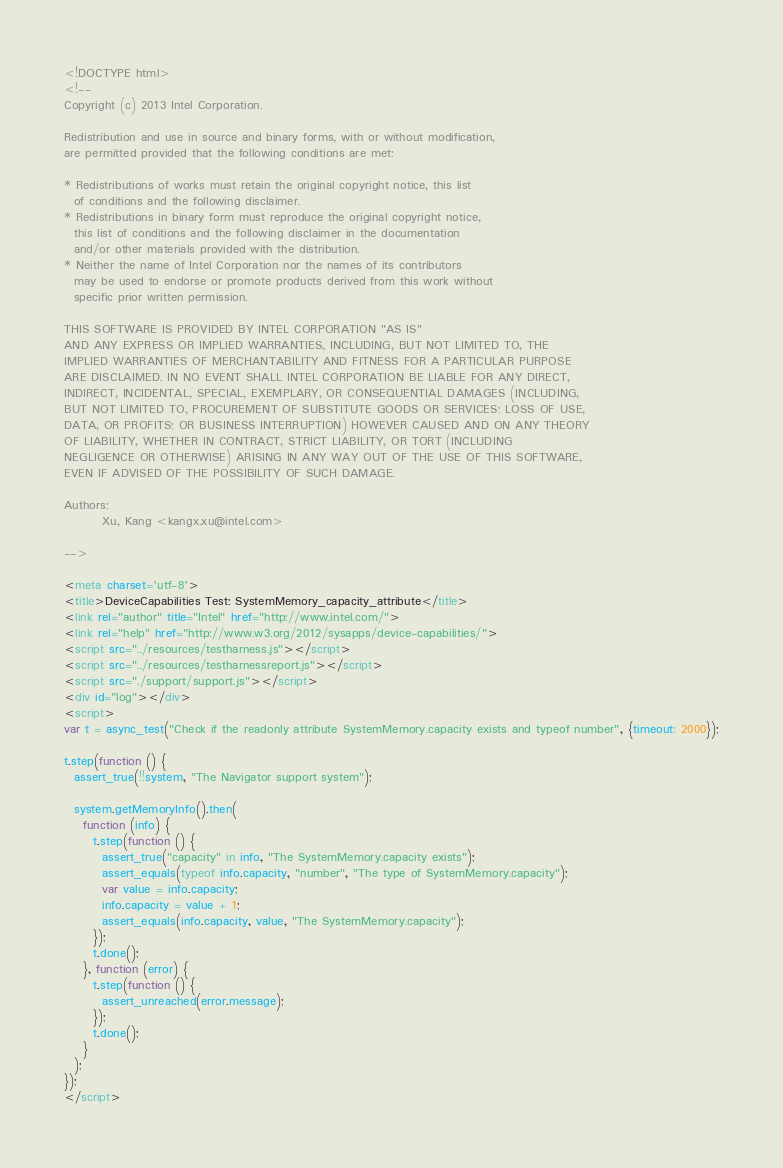Convert code to text. <code><loc_0><loc_0><loc_500><loc_500><_HTML_><!DOCTYPE html>
<!--
Copyright (c) 2013 Intel Corporation.

Redistribution and use in source and binary forms, with or without modification,
are permitted provided that the following conditions are met:

* Redistributions of works must retain the original copyright notice, this list
  of conditions and the following disclaimer.
* Redistributions in binary form must reproduce the original copyright notice,
  this list of conditions and the following disclaimer in the documentation
  and/or other materials provided with the distribution.
* Neither the name of Intel Corporation nor the names of its contributors
  may be used to endorse or promote products derived from this work without
  specific prior written permission.

THIS SOFTWARE IS PROVIDED BY INTEL CORPORATION "AS IS"
AND ANY EXPRESS OR IMPLIED WARRANTIES, INCLUDING, BUT NOT LIMITED TO, THE
IMPLIED WARRANTIES OF MERCHANTABILITY AND FITNESS FOR A PARTICULAR PURPOSE
ARE DISCLAIMED. IN NO EVENT SHALL INTEL CORPORATION BE LIABLE FOR ANY DIRECT,
INDIRECT, INCIDENTAL, SPECIAL, EXEMPLARY, OR CONSEQUENTIAL DAMAGES (INCLUDING,
BUT NOT LIMITED TO, PROCUREMENT OF SUBSTITUTE GOODS OR SERVICES; LOSS OF USE,
DATA, OR PROFITS; OR BUSINESS INTERRUPTION) HOWEVER CAUSED AND ON ANY THEORY
OF LIABILITY, WHETHER IN CONTRACT, STRICT LIABILITY, OR TORT (INCLUDING
NEGLIGENCE OR OTHERWISE) ARISING IN ANY WAY OUT OF THE USE OF THIS SOFTWARE,
EVEN IF ADVISED OF THE POSSIBILITY OF SUCH DAMAGE.

Authors:
        Xu, Kang <kangx.xu@intel.com>

-->

<meta charset='utf-8'>
<title>DeviceCapabilities Test: SystemMemory_capacity_attribute</title>
<link rel="author" title="Intel" href="http://www.intel.com/">
<link rel="help" href="http://www.w3.org/2012/sysapps/device-capabilities/">
<script src="../resources/testharness.js"></script>
<script src="../resources/testharnessreport.js"></script>
<script src="./support/support.js"></script>
<div id="log"></div>
<script>
var t = async_test("Check if the readonly attribute SystemMemory.capacity exists and typeof number", {timeout: 2000});

t.step(function () {
  assert_true(!!system, "The Navigator support system");

  system.getMemoryInfo().then(
    function (info) {
      t.step(function () {
        assert_true("capacity" in info, "The SystemMemory.capacity exists");
        assert_equals(typeof info.capacity, "number", "The type of SystemMemory.capacity");
        var value = info.capacity;
        info.capacity = value + 1;
        assert_equals(info.capacity, value, "The SystemMemory.capacity");
      });
      t.done();
    }, function (error) {
      t.step(function () {
        assert_unreached(error.message);
      });
      t.done();
    }
  );
});
</script>
</code> 